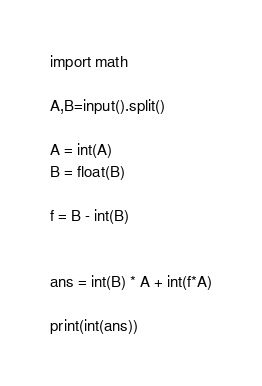<code> <loc_0><loc_0><loc_500><loc_500><_Python_>import math

A,B=input().split()

A = int(A)
B = float(B)

f = B - int(B)


ans = int(B) * A + int(f*A)

print(int(ans))</code> 